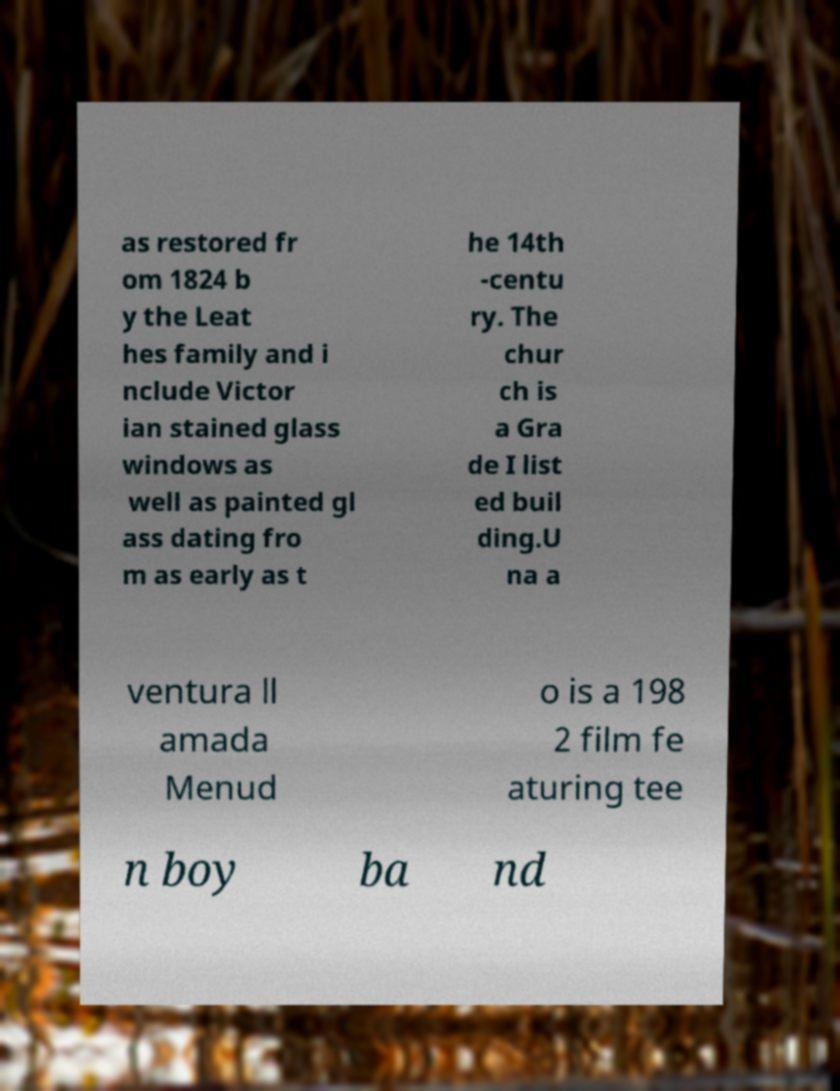For documentation purposes, I need the text within this image transcribed. Could you provide that? as restored fr om 1824 b y the Leat hes family and i nclude Victor ian stained glass windows as well as painted gl ass dating fro m as early as t he 14th -centu ry. The chur ch is a Gra de I list ed buil ding.U na a ventura ll amada Menud o is a 198 2 film fe aturing tee n boy ba nd 